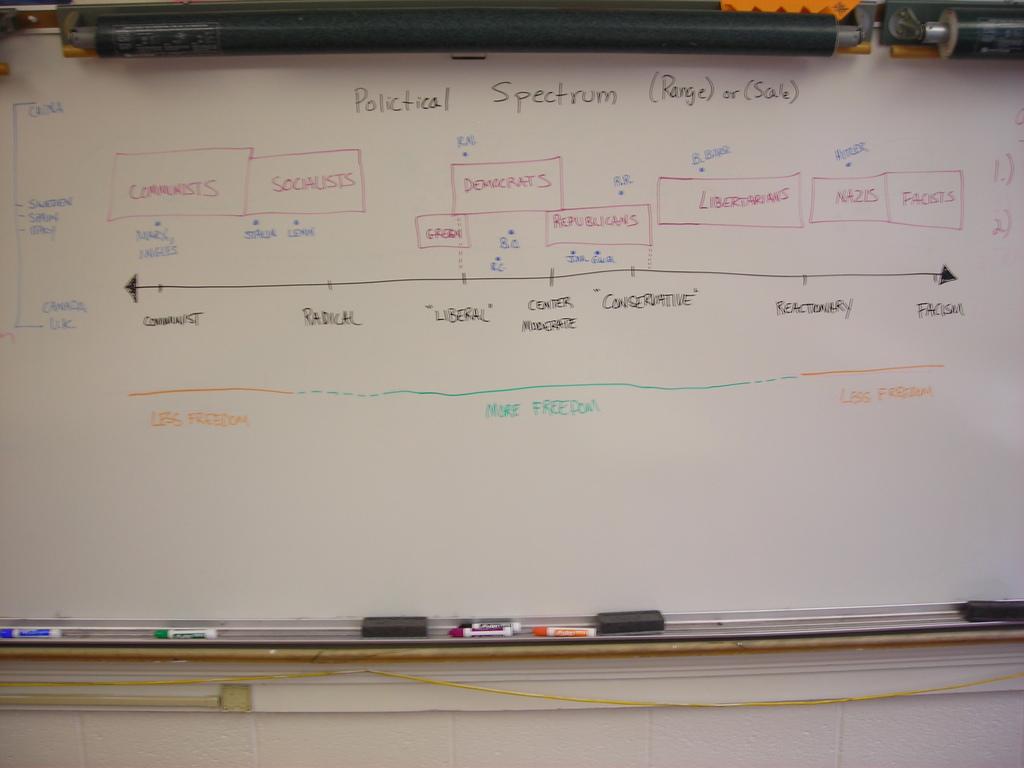This is the political what?
Your answer should be compact. Spectrum. What is the farthest right leaning person on this political spectrum?
Ensure brevity in your answer.  Facists. 